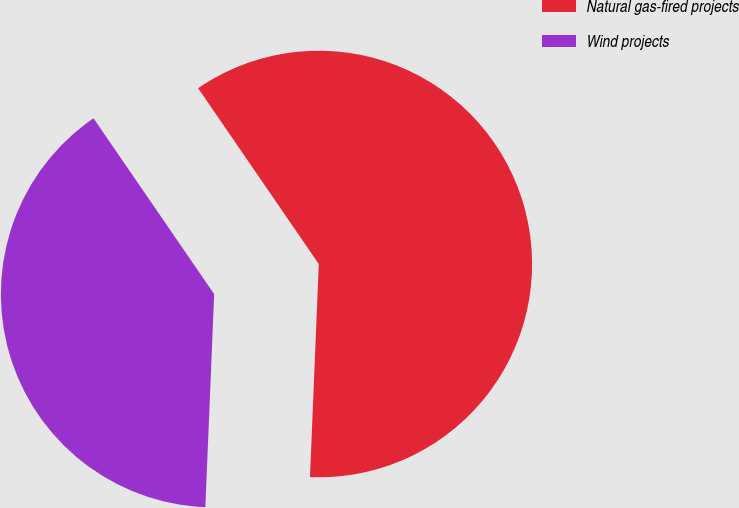<chart> <loc_0><loc_0><loc_500><loc_500><pie_chart><fcel>Natural gas-fired projects<fcel>Wind projects<nl><fcel>60.23%<fcel>39.77%<nl></chart> 